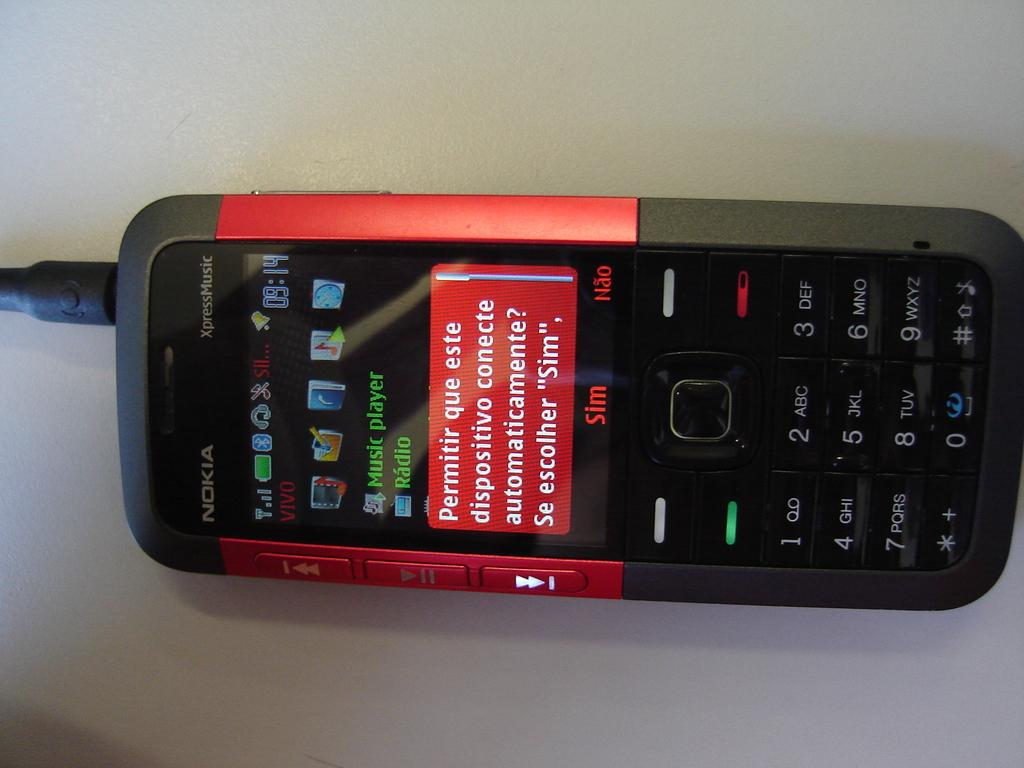Provide a one-sentence caption for the provided image. A black and red Nokia XpressMusic device with a small screen and keypad underneath it. 